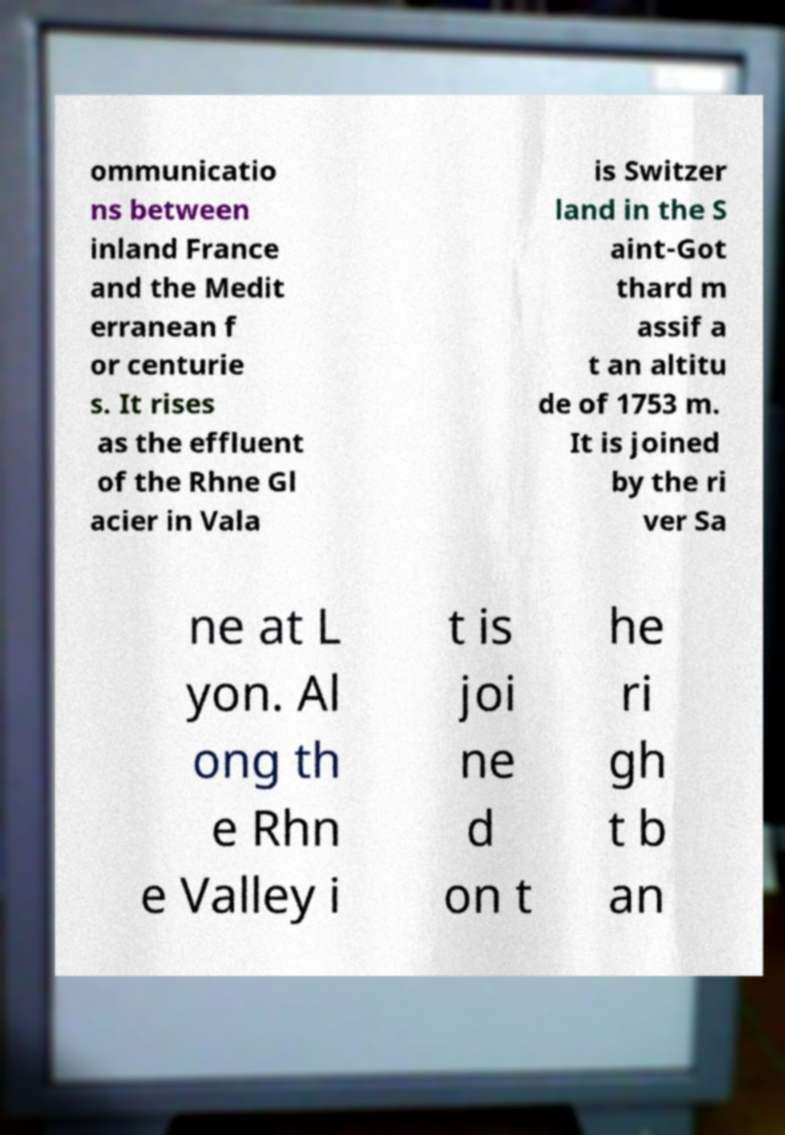For documentation purposes, I need the text within this image transcribed. Could you provide that? ommunicatio ns between inland France and the Medit erranean f or centurie s. It rises as the effluent of the Rhne Gl acier in Vala is Switzer land in the S aint-Got thard m assif a t an altitu de of 1753 m. It is joined by the ri ver Sa ne at L yon. Al ong th e Rhn e Valley i t is joi ne d on t he ri gh t b an 